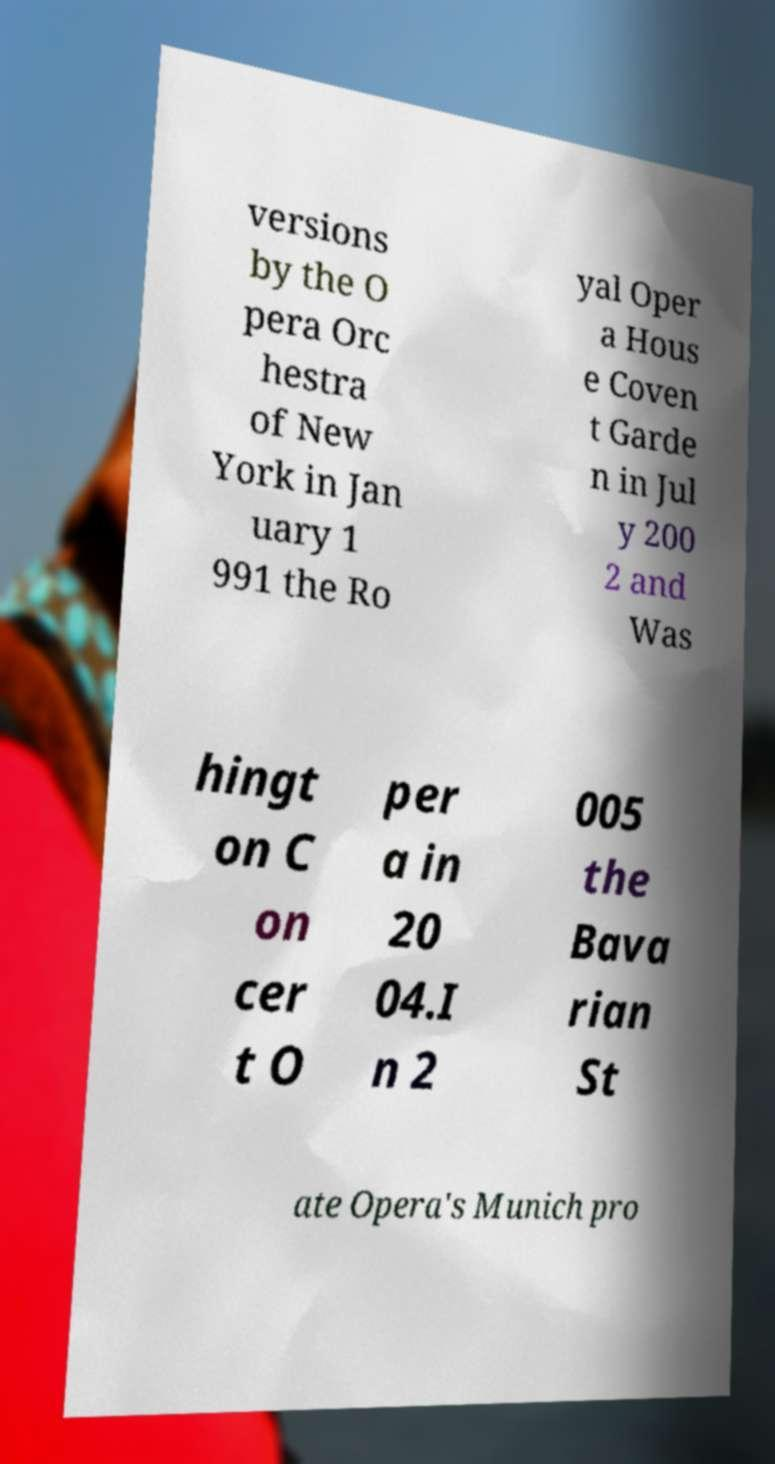Please read and relay the text visible in this image. What does it say? versions by the O pera Orc hestra of New York in Jan uary 1 991 the Ro yal Oper a Hous e Coven t Garde n in Jul y 200 2 and Was hingt on C on cer t O per a in 20 04.I n 2 005 the Bava rian St ate Opera's Munich pro 